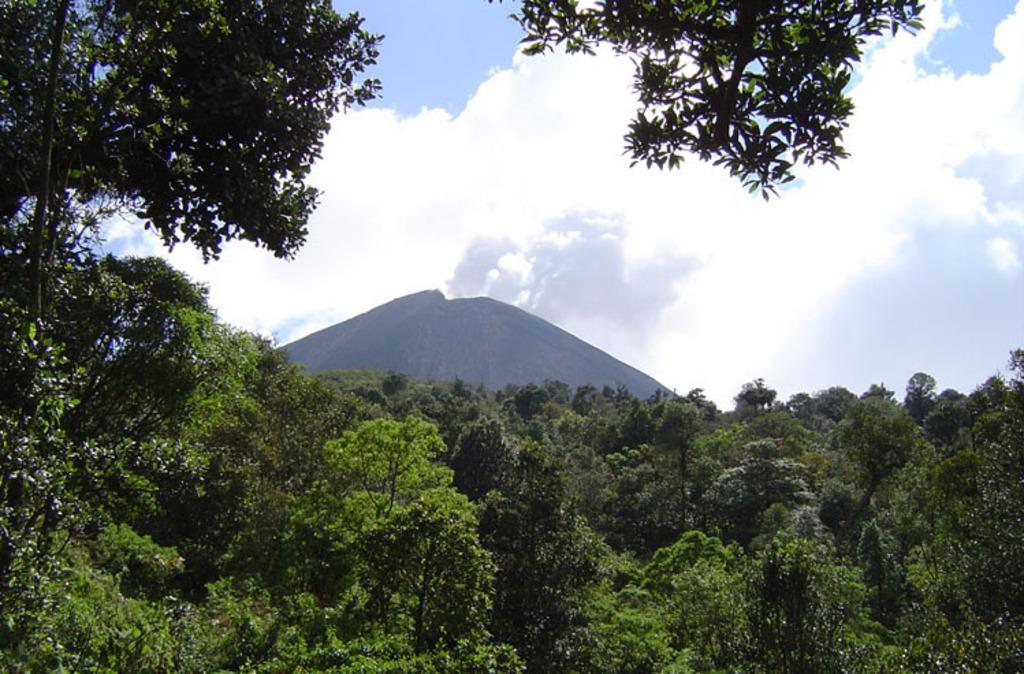How would you summarize this image in a sentence or two? In this image, I can see the trees and a hill. In the background, there is the sky. 